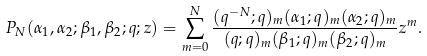<formula> <loc_0><loc_0><loc_500><loc_500>P _ { N } ( \alpha _ { 1 } , \alpha _ { 2 } ; \beta _ { 1 } , \beta _ { 2 } ; q ; z ) = \sum _ { m = 0 } ^ { N } \frac { ( q ^ { - N } ; q ) _ { m } ( \alpha _ { 1 } ; q ) _ { m } ( \alpha _ { 2 } ; q ) _ { m } } { ( q ; q ) _ { m } ( \beta _ { 1 } ; q ) _ { m } ( \beta _ { 2 } ; q ) _ { m } } z ^ { m } .</formula> 